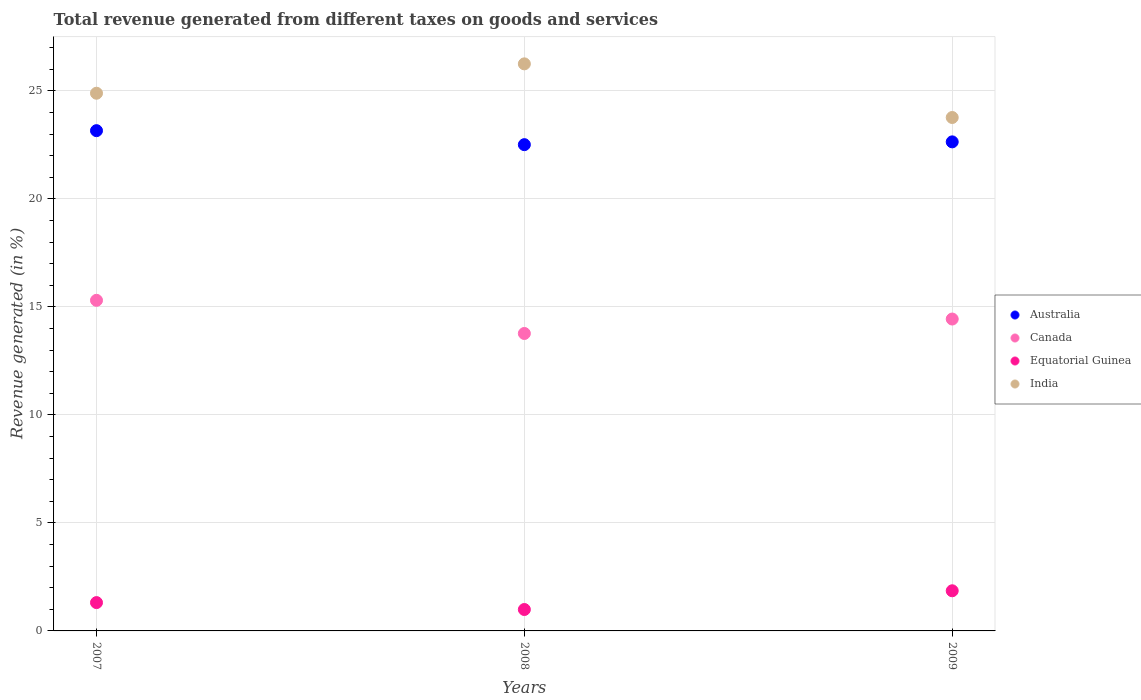What is the total revenue generated in Equatorial Guinea in 2007?
Your answer should be very brief. 1.31. Across all years, what is the maximum total revenue generated in Canada?
Make the answer very short. 15.3. Across all years, what is the minimum total revenue generated in Equatorial Guinea?
Give a very brief answer. 0.99. In which year was the total revenue generated in Canada maximum?
Provide a succinct answer. 2007. In which year was the total revenue generated in Australia minimum?
Your answer should be compact. 2008. What is the total total revenue generated in Canada in the graph?
Offer a very short reply. 43.51. What is the difference between the total revenue generated in India in 2007 and that in 2009?
Your answer should be compact. 1.12. What is the difference between the total revenue generated in India in 2008 and the total revenue generated in Equatorial Guinea in 2007?
Keep it short and to the point. 24.94. What is the average total revenue generated in India per year?
Your answer should be very brief. 24.97. In the year 2008, what is the difference between the total revenue generated in Equatorial Guinea and total revenue generated in Canada?
Provide a short and direct response. -12.78. What is the ratio of the total revenue generated in Equatorial Guinea in 2007 to that in 2009?
Offer a very short reply. 0.71. What is the difference between the highest and the second highest total revenue generated in India?
Make the answer very short. 1.36. What is the difference between the highest and the lowest total revenue generated in Canada?
Provide a short and direct response. 1.53. In how many years, is the total revenue generated in Canada greater than the average total revenue generated in Canada taken over all years?
Your answer should be very brief. 1. Is the sum of the total revenue generated in Equatorial Guinea in 2007 and 2008 greater than the maximum total revenue generated in India across all years?
Provide a succinct answer. No. Does the graph contain any zero values?
Your response must be concise. No. How are the legend labels stacked?
Your response must be concise. Vertical. What is the title of the graph?
Provide a succinct answer. Total revenue generated from different taxes on goods and services. Does "Greece" appear as one of the legend labels in the graph?
Your answer should be compact. No. What is the label or title of the X-axis?
Your response must be concise. Years. What is the label or title of the Y-axis?
Your answer should be compact. Revenue generated (in %). What is the Revenue generated (in %) of Australia in 2007?
Offer a very short reply. 23.16. What is the Revenue generated (in %) in Canada in 2007?
Offer a very short reply. 15.3. What is the Revenue generated (in %) of Equatorial Guinea in 2007?
Provide a succinct answer. 1.31. What is the Revenue generated (in %) in India in 2007?
Provide a succinct answer. 24.89. What is the Revenue generated (in %) of Australia in 2008?
Your answer should be compact. 22.51. What is the Revenue generated (in %) of Canada in 2008?
Provide a succinct answer. 13.77. What is the Revenue generated (in %) of Equatorial Guinea in 2008?
Your answer should be very brief. 0.99. What is the Revenue generated (in %) in India in 2008?
Provide a short and direct response. 26.25. What is the Revenue generated (in %) in Australia in 2009?
Your answer should be very brief. 22.64. What is the Revenue generated (in %) in Canada in 2009?
Ensure brevity in your answer.  14.44. What is the Revenue generated (in %) in Equatorial Guinea in 2009?
Provide a short and direct response. 1.86. What is the Revenue generated (in %) of India in 2009?
Give a very brief answer. 23.76. Across all years, what is the maximum Revenue generated (in %) of Australia?
Keep it short and to the point. 23.16. Across all years, what is the maximum Revenue generated (in %) in Canada?
Make the answer very short. 15.3. Across all years, what is the maximum Revenue generated (in %) in Equatorial Guinea?
Offer a terse response. 1.86. Across all years, what is the maximum Revenue generated (in %) in India?
Your answer should be compact. 26.25. Across all years, what is the minimum Revenue generated (in %) of Australia?
Make the answer very short. 22.51. Across all years, what is the minimum Revenue generated (in %) in Canada?
Provide a succinct answer. 13.77. Across all years, what is the minimum Revenue generated (in %) of Equatorial Guinea?
Provide a succinct answer. 0.99. Across all years, what is the minimum Revenue generated (in %) of India?
Your answer should be compact. 23.76. What is the total Revenue generated (in %) in Australia in the graph?
Offer a very short reply. 68.3. What is the total Revenue generated (in %) of Canada in the graph?
Provide a succinct answer. 43.51. What is the total Revenue generated (in %) in Equatorial Guinea in the graph?
Make the answer very short. 4.16. What is the total Revenue generated (in %) in India in the graph?
Make the answer very short. 74.9. What is the difference between the Revenue generated (in %) of Australia in 2007 and that in 2008?
Provide a short and direct response. 0.65. What is the difference between the Revenue generated (in %) of Canada in 2007 and that in 2008?
Provide a succinct answer. 1.53. What is the difference between the Revenue generated (in %) of Equatorial Guinea in 2007 and that in 2008?
Offer a very short reply. 0.32. What is the difference between the Revenue generated (in %) in India in 2007 and that in 2008?
Offer a very short reply. -1.36. What is the difference between the Revenue generated (in %) in Australia in 2007 and that in 2009?
Ensure brevity in your answer.  0.52. What is the difference between the Revenue generated (in %) in Canada in 2007 and that in 2009?
Keep it short and to the point. 0.87. What is the difference between the Revenue generated (in %) in Equatorial Guinea in 2007 and that in 2009?
Your response must be concise. -0.55. What is the difference between the Revenue generated (in %) of India in 2007 and that in 2009?
Give a very brief answer. 1.12. What is the difference between the Revenue generated (in %) of Australia in 2008 and that in 2009?
Provide a short and direct response. -0.13. What is the difference between the Revenue generated (in %) in Canada in 2008 and that in 2009?
Provide a succinct answer. -0.67. What is the difference between the Revenue generated (in %) in Equatorial Guinea in 2008 and that in 2009?
Provide a succinct answer. -0.87. What is the difference between the Revenue generated (in %) in India in 2008 and that in 2009?
Ensure brevity in your answer.  2.48. What is the difference between the Revenue generated (in %) in Australia in 2007 and the Revenue generated (in %) in Canada in 2008?
Your response must be concise. 9.39. What is the difference between the Revenue generated (in %) in Australia in 2007 and the Revenue generated (in %) in Equatorial Guinea in 2008?
Give a very brief answer. 22.16. What is the difference between the Revenue generated (in %) in Australia in 2007 and the Revenue generated (in %) in India in 2008?
Ensure brevity in your answer.  -3.09. What is the difference between the Revenue generated (in %) of Canada in 2007 and the Revenue generated (in %) of Equatorial Guinea in 2008?
Keep it short and to the point. 14.31. What is the difference between the Revenue generated (in %) of Canada in 2007 and the Revenue generated (in %) of India in 2008?
Provide a short and direct response. -10.95. What is the difference between the Revenue generated (in %) of Equatorial Guinea in 2007 and the Revenue generated (in %) of India in 2008?
Provide a succinct answer. -24.94. What is the difference between the Revenue generated (in %) in Australia in 2007 and the Revenue generated (in %) in Canada in 2009?
Offer a very short reply. 8.72. What is the difference between the Revenue generated (in %) of Australia in 2007 and the Revenue generated (in %) of Equatorial Guinea in 2009?
Your answer should be compact. 21.3. What is the difference between the Revenue generated (in %) of Australia in 2007 and the Revenue generated (in %) of India in 2009?
Provide a succinct answer. -0.61. What is the difference between the Revenue generated (in %) in Canada in 2007 and the Revenue generated (in %) in Equatorial Guinea in 2009?
Give a very brief answer. 13.44. What is the difference between the Revenue generated (in %) of Canada in 2007 and the Revenue generated (in %) of India in 2009?
Provide a succinct answer. -8.46. What is the difference between the Revenue generated (in %) in Equatorial Guinea in 2007 and the Revenue generated (in %) in India in 2009?
Offer a terse response. -22.45. What is the difference between the Revenue generated (in %) of Australia in 2008 and the Revenue generated (in %) of Canada in 2009?
Make the answer very short. 8.07. What is the difference between the Revenue generated (in %) in Australia in 2008 and the Revenue generated (in %) in Equatorial Guinea in 2009?
Ensure brevity in your answer.  20.65. What is the difference between the Revenue generated (in %) of Australia in 2008 and the Revenue generated (in %) of India in 2009?
Make the answer very short. -1.26. What is the difference between the Revenue generated (in %) of Canada in 2008 and the Revenue generated (in %) of Equatorial Guinea in 2009?
Offer a very short reply. 11.91. What is the difference between the Revenue generated (in %) of Canada in 2008 and the Revenue generated (in %) of India in 2009?
Ensure brevity in your answer.  -10. What is the difference between the Revenue generated (in %) in Equatorial Guinea in 2008 and the Revenue generated (in %) in India in 2009?
Make the answer very short. -22.77. What is the average Revenue generated (in %) in Australia per year?
Offer a very short reply. 22.77. What is the average Revenue generated (in %) in Canada per year?
Ensure brevity in your answer.  14.5. What is the average Revenue generated (in %) in Equatorial Guinea per year?
Your response must be concise. 1.39. What is the average Revenue generated (in %) of India per year?
Offer a terse response. 24.97. In the year 2007, what is the difference between the Revenue generated (in %) in Australia and Revenue generated (in %) in Canada?
Provide a short and direct response. 7.85. In the year 2007, what is the difference between the Revenue generated (in %) in Australia and Revenue generated (in %) in Equatorial Guinea?
Provide a short and direct response. 21.84. In the year 2007, what is the difference between the Revenue generated (in %) of Australia and Revenue generated (in %) of India?
Ensure brevity in your answer.  -1.73. In the year 2007, what is the difference between the Revenue generated (in %) in Canada and Revenue generated (in %) in Equatorial Guinea?
Make the answer very short. 13.99. In the year 2007, what is the difference between the Revenue generated (in %) of Canada and Revenue generated (in %) of India?
Ensure brevity in your answer.  -9.59. In the year 2007, what is the difference between the Revenue generated (in %) of Equatorial Guinea and Revenue generated (in %) of India?
Your answer should be very brief. -23.58. In the year 2008, what is the difference between the Revenue generated (in %) of Australia and Revenue generated (in %) of Canada?
Ensure brevity in your answer.  8.74. In the year 2008, what is the difference between the Revenue generated (in %) in Australia and Revenue generated (in %) in Equatorial Guinea?
Provide a succinct answer. 21.52. In the year 2008, what is the difference between the Revenue generated (in %) of Australia and Revenue generated (in %) of India?
Your response must be concise. -3.74. In the year 2008, what is the difference between the Revenue generated (in %) of Canada and Revenue generated (in %) of Equatorial Guinea?
Your response must be concise. 12.78. In the year 2008, what is the difference between the Revenue generated (in %) of Canada and Revenue generated (in %) of India?
Offer a very short reply. -12.48. In the year 2008, what is the difference between the Revenue generated (in %) of Equatorial Guinea and Revenue generated (in %) of India?
Your response must be concise. -25.26. In the year 2009, what is the difference between the Revenue generated (in %) in Australia and Revenue generated (in %) in Canada?
Provide a short and direct response. 8.2. In the year 2009, what is the difference between the Revenue generated (in %) of Australia and Revenue generated (in %) of Equatorial Guinea?
Your answer should be compact. 20.78. In the year 2009, what is the difference between the Revenue generated (in %) in Australia and Revenue generated (in %) in India?
Ensure brevity in your answer.  -1.13. In the year 2009, what is the difference between the Revenue generated (in %) of Canada and Revenue generated (in %) of Equatorial Guinea?
Ensure brevity in your answer.  12.58. In the year 2009, what is the difference between the Revenue generated (in %) of Canada and Revenue generated (in %) of India?
Make the answer very short. -9.33. In the year 2009, what is the difference between the Revenue generated (in %) in Equatorial Guinea and Revenue generated (in %) in India?
Your response must be concise. -21.91. What is the ratio of the Revenue generated (in %) of Australia in 2007 to that in 2008?
Give a very brief answer. 1.03. What is the ratio of the Revenue generated (in %) in Canada in 2007 to that in 2008?
Give a very brief answer. 1.11. What is the ratio of the Revenue generated (in %) of Equatorial Guinea in 2007 to that in 2008?
Ensure brevity in your answer.  1.32. What is the ratio of the Revenue generated (in %) in India in 2007 to that in 2008?
Your response must be concise. 0.95. What is the ratio of the Revenue generated (in %) of Australia in 2007 to that in 2009?
Give a very brief answer. 1.02. What is the ratio of the Revenue generated (in %) of Canada in 2007 to that in 2009?
Your answer should be very brief. 1.06. What is the ratio of the Revenue generated (in %) in Equatorial Guinea in 2007 to that in 2009?
Your response must be concise. 0.71. What is the ratio of the Revenue generated (in %) in India in 2007 to that in 2009?
Provide a succinct answer. 1.05. What is the ratio of the Revenue generated (in %) of Australia in 2008 to that in 2009?
Your answer should be compact. 0.99. What is the ratio of the Revenue generated (in %) in Canada in 2008 to that in 2009?
Make the answer very short. 0.95. What is the ratio of the Revenue generated (in %) in Equatorial Guinea in 2008 to that in 2009?
Your answer should be very brief. 0.53. What is the ratio of the Revenue generated (in %) of India in 2008 to that in 2009?
Keep it short and to the point. 1.1. What is the difference between the highest and the second highest Revenue generated (in %) of Australia?
Offer a terse response. 0.52. What is the difference between the highest and the second highest Revenue generated (in %) in Canada?
Your response must be concise. 0.87. What is the difference between the highest and the second highest Revenue generated (in %) of Equatorial Guinea?
Ensure brevity in your answer.  0.55. What is the difference between the highest and the second highest Revenue generated (in %) of India?
Your answer should be compact. 1.36. What is the difference between the highest and the lowest Revenue generated (in %) of Australia?
Your answer should be very brief. 0.65. What is the difference between the highest and the lowest Revenue generated (in %) in Canada?
Provide a short and direct response. 1.53. What is the difference between the highest and the lowest Revenue generated (in %) of Equatorial Guinea?
Offer a terse response. 0.87. What is the difference between the highest and the lowest Revenue generated (in %) in India?
Offer a terse response. 2.48. 